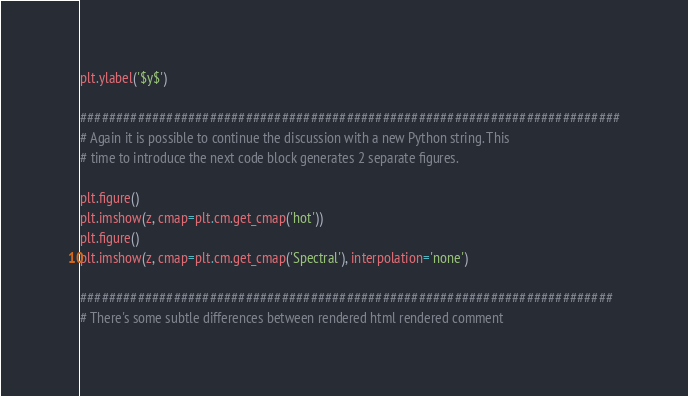<code> <loc_0><loc_0><loc_500><loc_500><_Python_>plt.ylabel('$y$')

###########################################################################
# Again it is possible to continue the discussion with a new Python string. This
# time to introduce the next code block generates 2 separate figures.

plt.figure()
plt.imshow(z, cmap=plt.cm.get_cmap('hot'))
plt.figure()
plt.imshow(z, cmap=plt.cm.get_cmap('Spectral'), interpolation='none')

##########################################################################
# There's some subtle differences between rendered html rendered comment</code> 